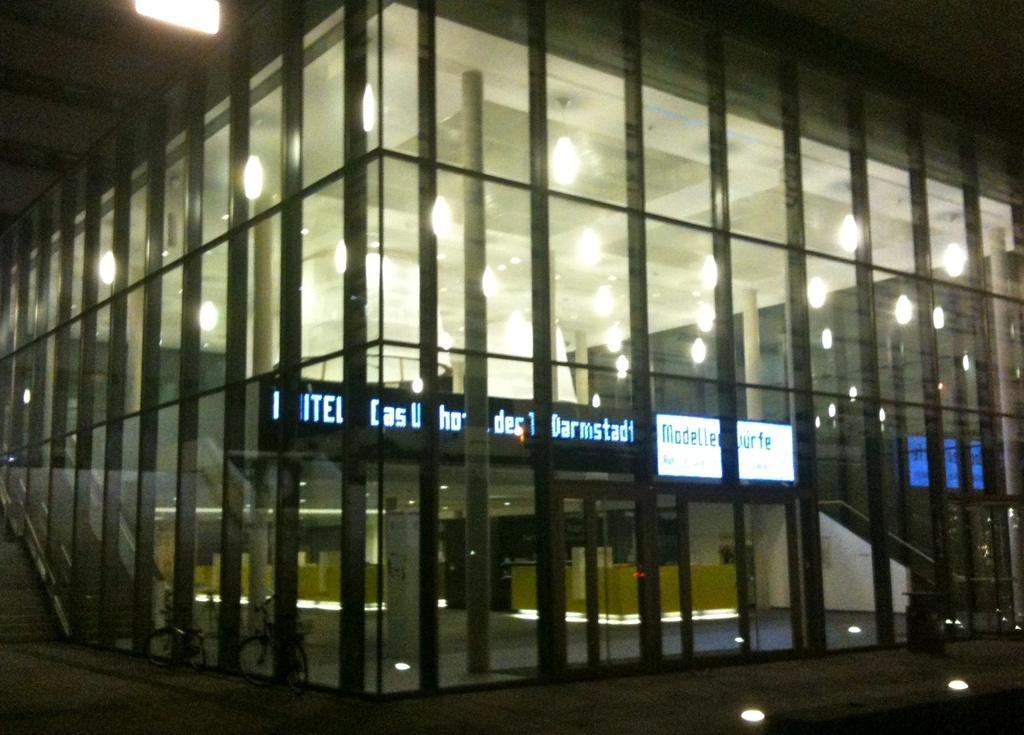Please provide a concise description of this image. In this picture we can see bicycles on the path. There are lights, some text on the boards and a few objects visible in the building. 